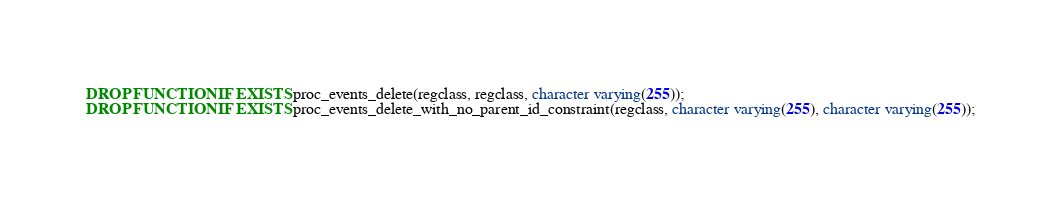<code> <loc_0><loc_0><loc_500><loc_500><_SQL_>DROP FUNCTION IF EXISTS proc_events_delete(regclass, regclass, character varying(255));
DROP FUNCTION IF EXISTS proc_events_delete_with_no_parent_id_constraint(regclass, character varying(255), character varying(255));
</code> 